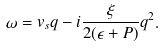<formula> <loc_0><loc_0><loc_500><loc_500>\omega = v _ { s } q - i \frac { \xi } { 2 ( \epsilon + P ) } q ^ { 2 } .</formula> 